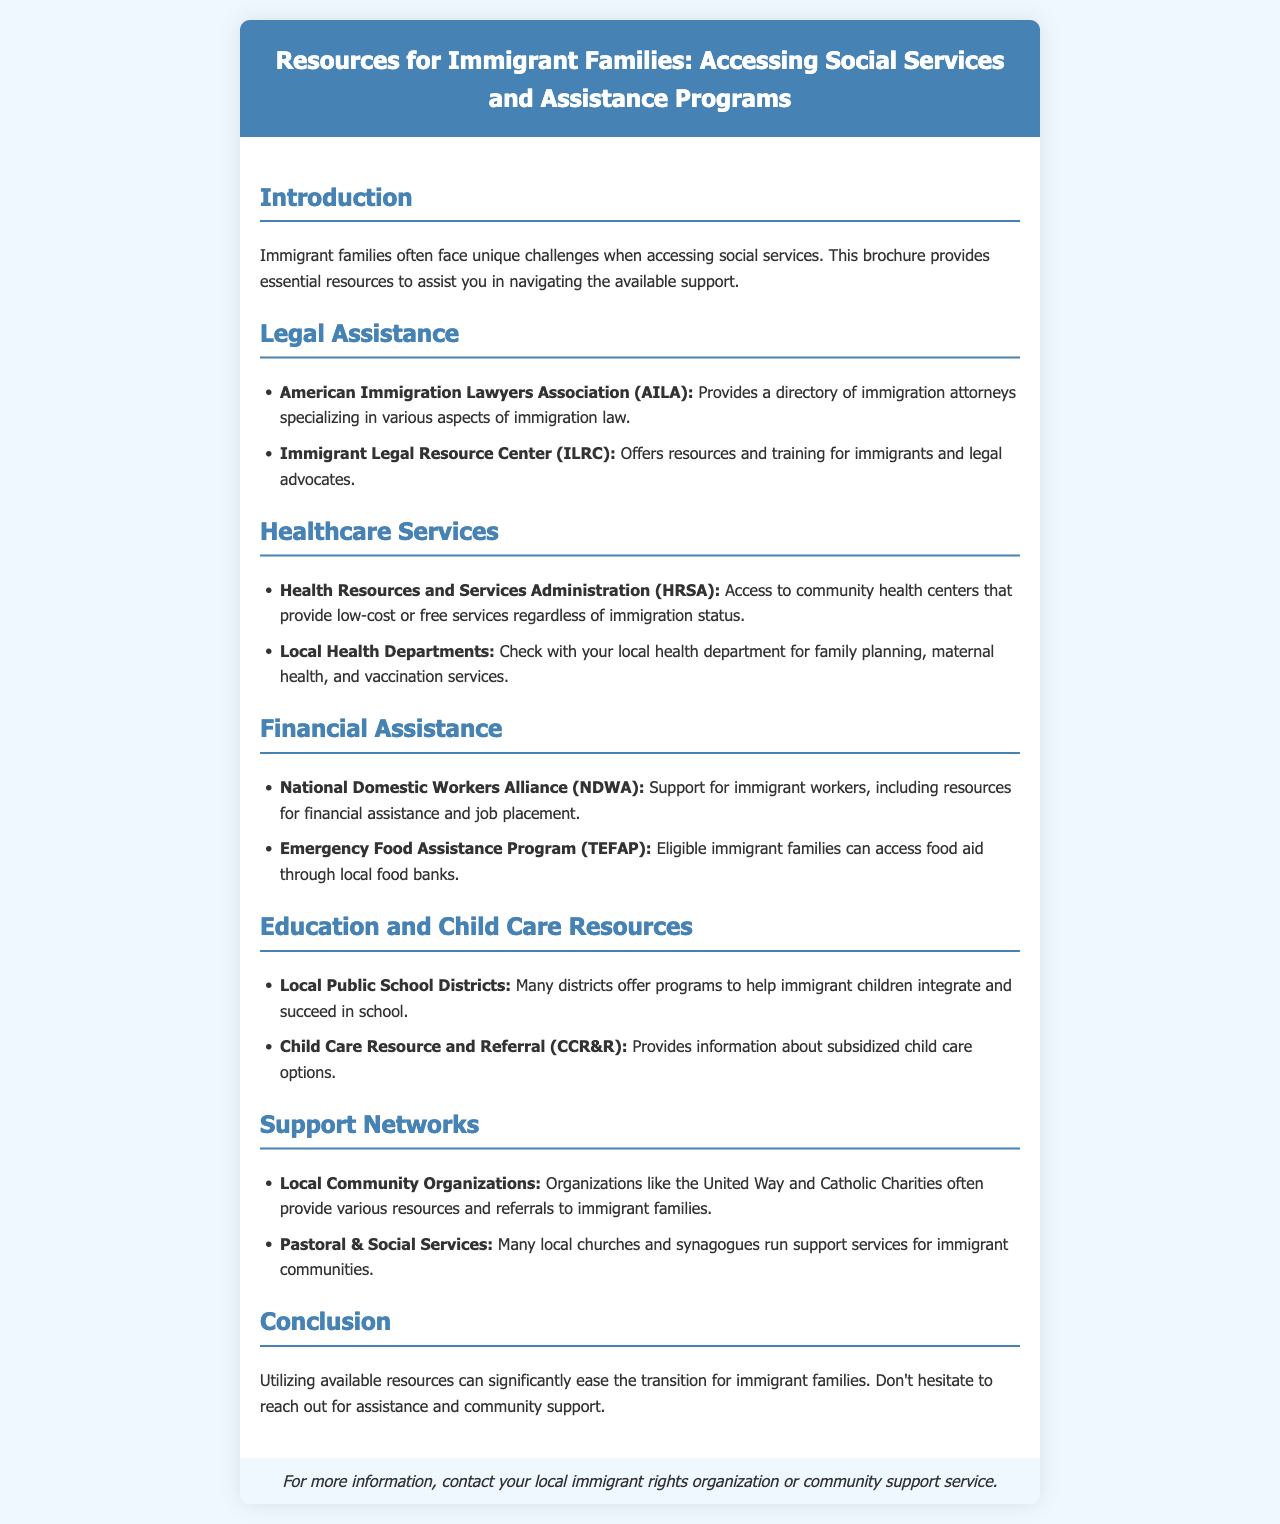what organization provides a directory of immigration attorneys? The document states that the American Immigration Lawyers Association (AILA) provides a directory of immigration attorneys.
Answer: American Immigration Lawyers Association (AILA) what type of services does HRSA offer? The document mentions that HRSA provides access to community health centers that offer low-cost or free services.
Answer: community health centers who can access the Emergency Food Assistance Program? According to the document, eligible immigrant families can access food aid through local food banks.
Answer: eligible immigrant families what type of resources do local public school districts offer? The brochure states that many districts offer programs to help immigrant children integrate and succeed in school.
Answer: programs for immigrant children which organization supports immigrant workers? The document lists the National Domestic Workers Alliance (NDWA) as a supporter of immigrant workers.
Answer: National Domestic Workers Alliance (NDWA) how do local community organizations assist immigrant families? The document indicates that organizations like the United Way and Catholic Charities provide various resources and referrals.
Answer: various resources and referrals what is a key focus of pastoral and social services? The document describes that many local churches and synagogues run support services for immigrant communities.
Answer: support services for immigrant communities what is the main objective of this brochure? The brochure aims to assist immigrant families in navigating available support and resources.
Answer: assist immigrant families 